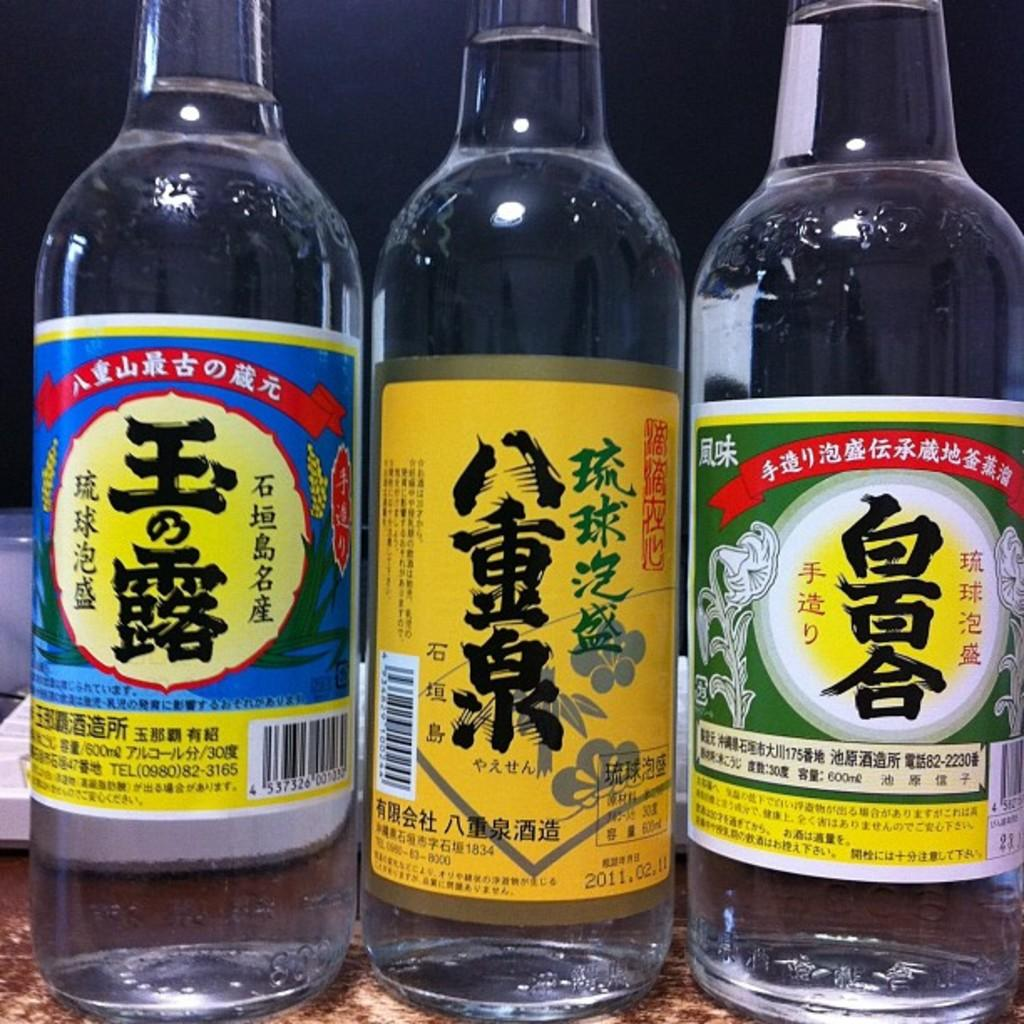<image>
Provide a brief description of the given image. bottles of colorful Chinese liquor with expiration date 2011.02.11 